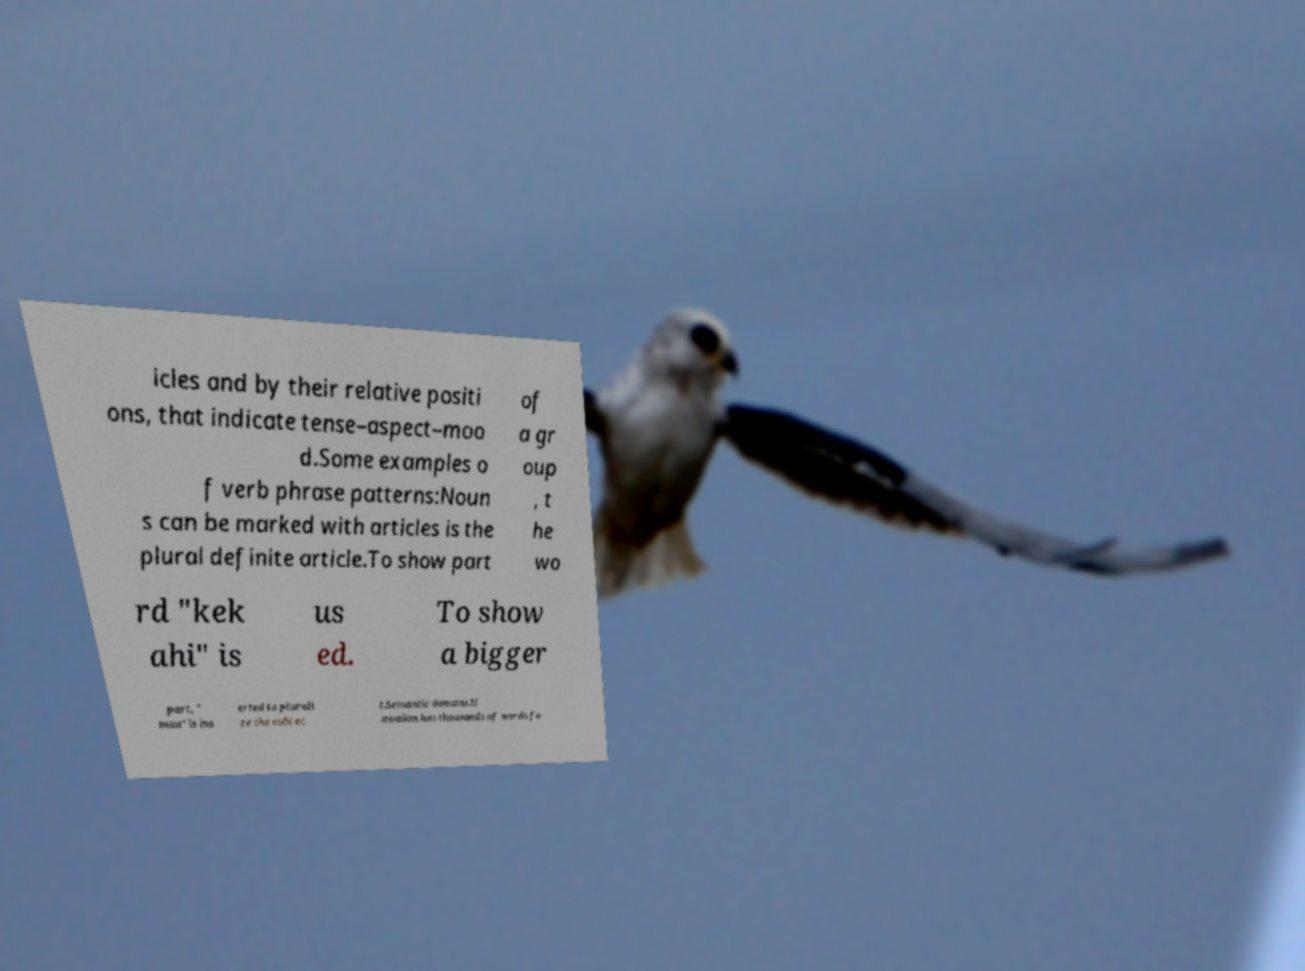Please identify and transcribe the text found in this image. icles and by their relative positi ons, that indicate tense–aspect–moo d.Some examples o f verb phrase patterns:Noun s can be marked with articles is the plural definite article.To show part of a gr oup , t he wo rd "kek ahi" is us ed. To show a bigger part, " mau" is ins erted to plurali ze the subjec t.Semantic domains.H awaiian has thousands of words fo 